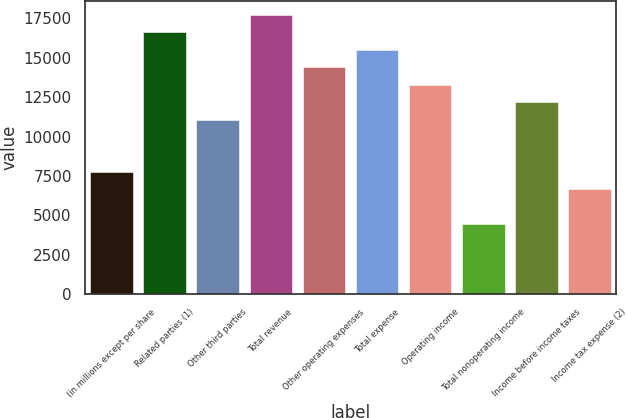Convert chart. <chart><loc_0><loc_0><loc_500><loc_500><bar_chart><fcel>(in millions except per share<fcel>Related parties (1)<fcel>Other third parties<fcel>Total revenue<fcel>Other operating expenses<fcel>Total expense<fcel>Operating income<fcel>Total nonoperating income<fcel>Income before income taxes<fcel>Income tax expense (2)<nl><fcel>7759.03<fcel>16617.7<fcel>11081<fcel>17725<fcel>14403<fcel>15510.3<fcel>13295.7<fcel>4437.04<fcel>12188.4<fcel>6651.7<nl></chart> 